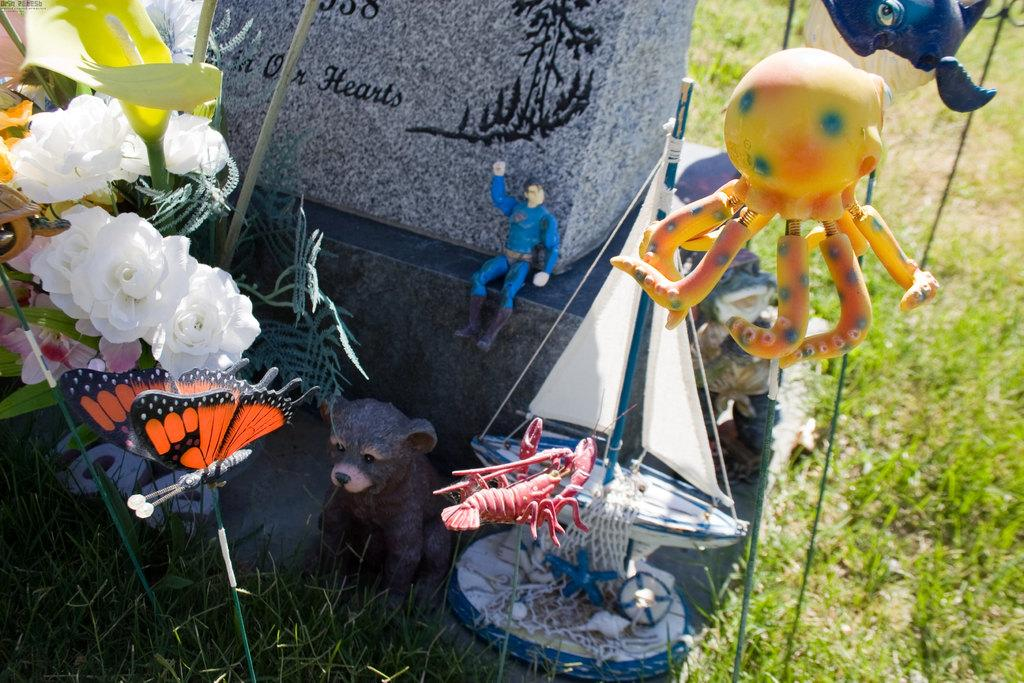What objects can be seen in the foreground of the image? There are toys and a stone-like object in the foreground of the image. Where is the flower vase located in the image? The flower vase is on the left side of the image. What type of vegetation is visible on the right side of the image? There is grass on the right side of the image. How many boats are visible in the image? There are no boats present in the image. What type of playground equipment can be seen in the image? There is no playground equipment present in the image. 